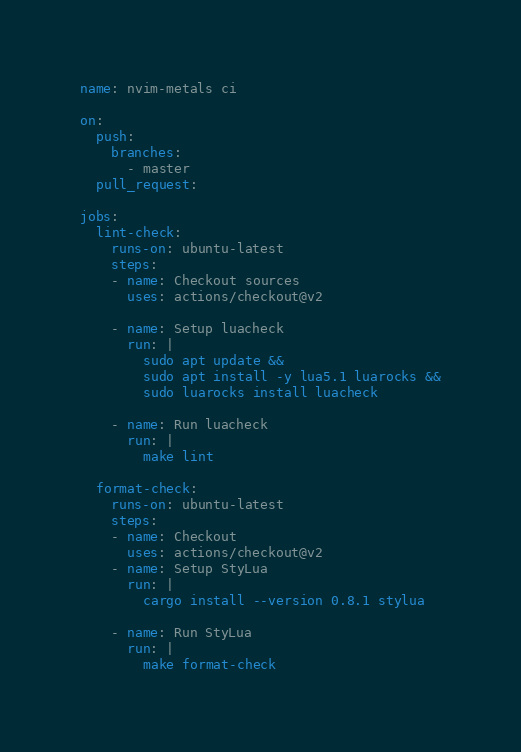<code> <loc_0><loc_0><loc_500><loc_500><_YAML_>name: nvim-metals ci

on:
  push:
    branches:
      - master
  pull_request:

jobs:
  lint-check:
    runs-on: ubuntu-latest
    steps:
    - name: Checkout sources
      uses: actions/checkout@v2

    - name: Setup luacheck
      run: |
        sudo apt update &&
        sudo apt install -y lua5.1 luarocks &&
        sudo luarocks install luacheck

    - name: Run luacheck
      run: |
        make lint

  format-check:
    runs-on: ubuntu-latest
    steps:
    - name: Checkout
      uses: actions/checkout@v2
    - name: Setup StyLua
      run: |
        cargo install --version 0.8.1 stylua

    - name: Run StyLua
      run: |
        make format-check
</code> 